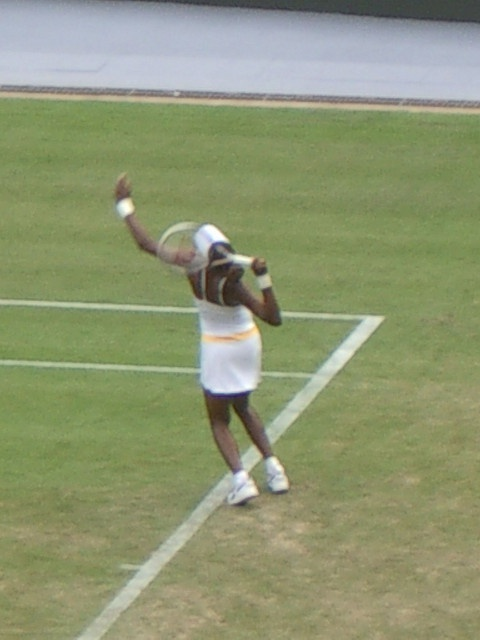Describe the objects in this image and their specific colors. I can see people in gray, olive, lightgray, and darkgray tones and tennis racket in gray, darkgray, and lightgray tones in this image. 